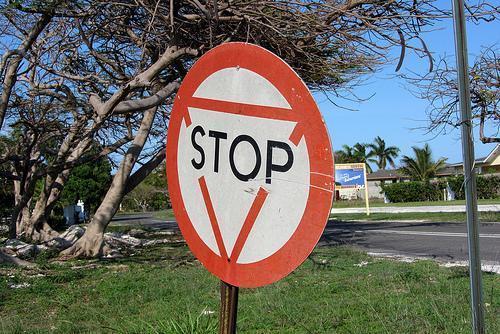How many signs can be seen in the image?
Give a very brief answer. 2. 